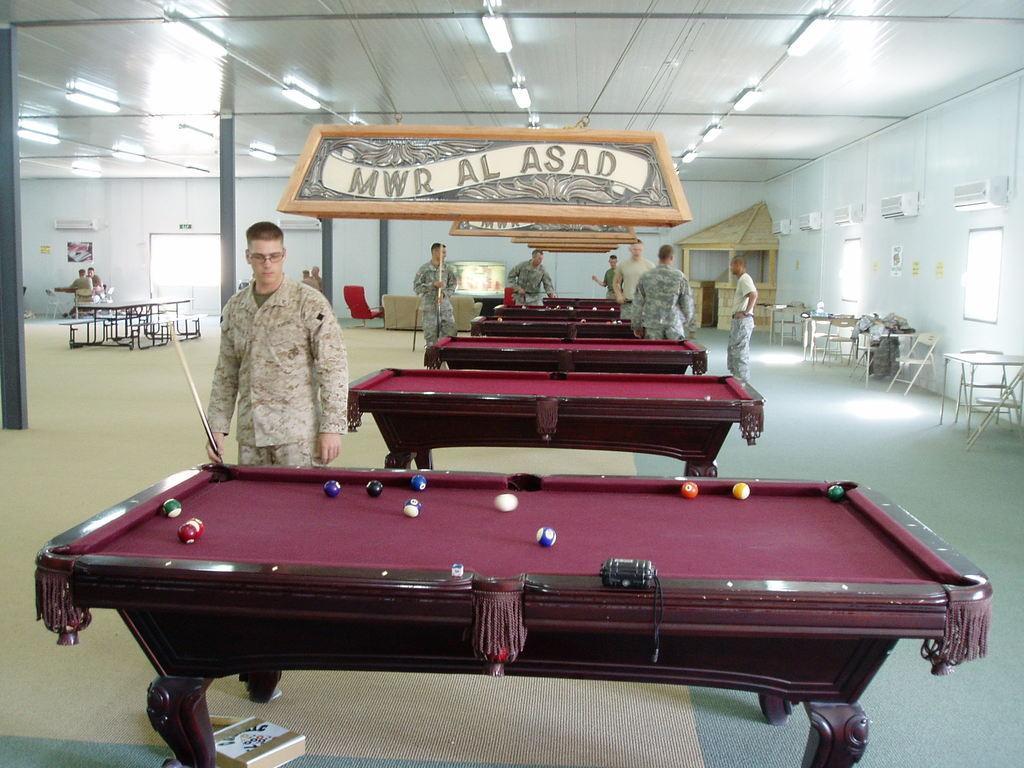How would you summarize this image in a sentence or two? This picture shows few men playing pool and we see few pool tables. 